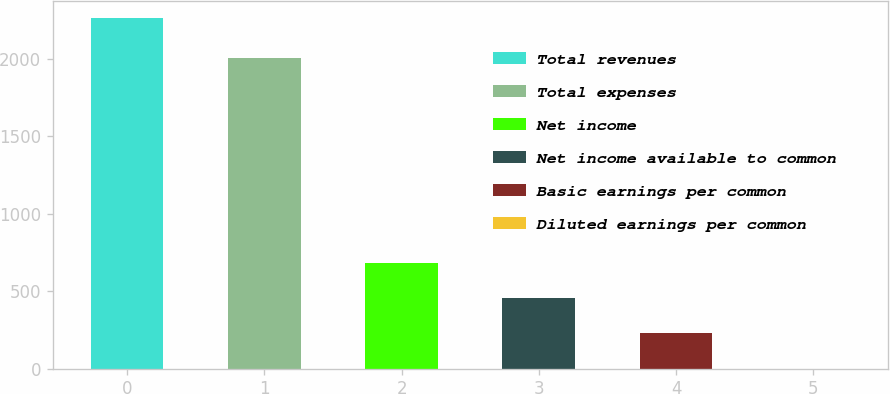Convert chart. <chart><loc_0><loc_0><loc_500><loc_500><bar_chart><fcel>Total revenues<fcel>Total expenses<fcel>Net income<fcel>Net income available to common<fcel>Basic earnings per common<fcel>Diluted earnings per common<nl><fcel>2264<fcel>2007.7<fcel>679.61<fcel>453.27<fcel>226.93<fcel>0.59<nl></chart> 